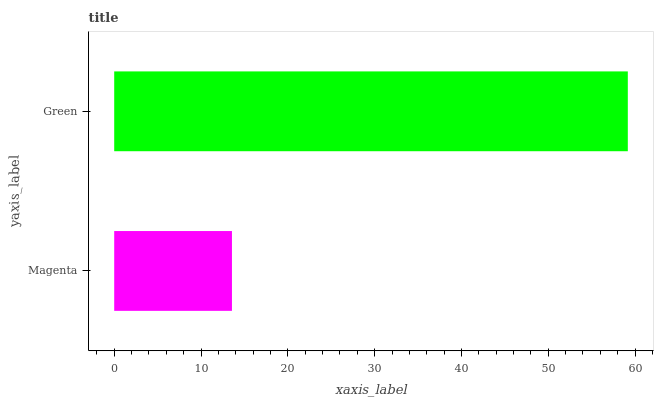Is Magenta the minimum?
Answer yes or no. Yes. Is Green the maximum?
Answer yes or no. Yes. Is Green the minimum?
Answer yes or no. No. Is Green greater than Magenta?
Answer yes or no. Yes. Is Magenta less than Green?
Answer yes or no. Yes. Is Magenta greater than Green?
Answer yes or no. No. Is Green less than Magenta?
Answer yes or no. No. Is Green the high median?
Answer yes or no. Yes. Is Magenta the low median?
Answer yes or no. Yes. Is Magenta the high median?
Answer yes or no. No. Is Green the low median?
Answer yes or no. No. 